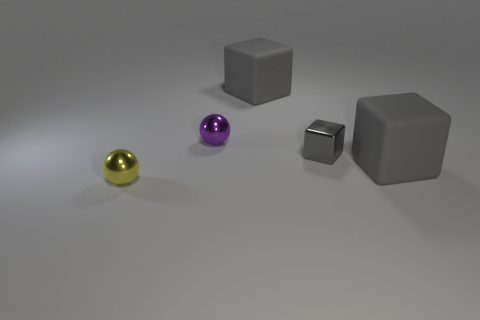How many objects are yellow things or blocks?
Keep it short and to the point. 4. What shape is the small purple object that is the same material as the tiny yellow thing?
Ensure brevity in your answer.  Sphere. What is the size of the gray matte cube that is behind the matte cube to the right of the tiny gray cube?
Provide a short and direct response. Large. How many big things are gray rubber cubes or yellow balls?
Keep it short and to the point. 2. What number of other things are the same color as the metallic block?
Keep it short and to the point. 2. There is a purple metal thing right of the small yellow metallic object; is it the same size as the thing right of the gray metal block?
Give a very brief answer. No. Does the purple sphere have the same material as the tiny ball in front of the purple ball?
Provide a succinct answer. Yes. Are there more shiny things on the right side of the tiny yellow sphere than small gray metal objects behind the tiny shiny cube?
Give a very brief answer. Yes. There is a big block to the right of the tiny gray block behind the yellow metal ball; what is its color?
Offer a terse response. Gray. How many cylinders are big things or small purple things?
Keep it short and to the point. 0. 